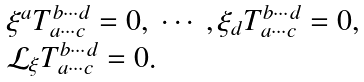Convert formula to latex. <formula><loc_0><loc_0><loc_500><loc_500>\begin{array} { l } \xi ^ { a } T ^ { b \cdots d } _ { a \cdots c } = 0 , \ \cdots \ , \xi _ { d } T ^ { b \cdots d } _ { a \cdots c } = 0 , \\ { \mathcal { L } } _ { \xi } T ^ { b \cdots d } _ { a \cdots c } = 0 . \end{array}</formula> 